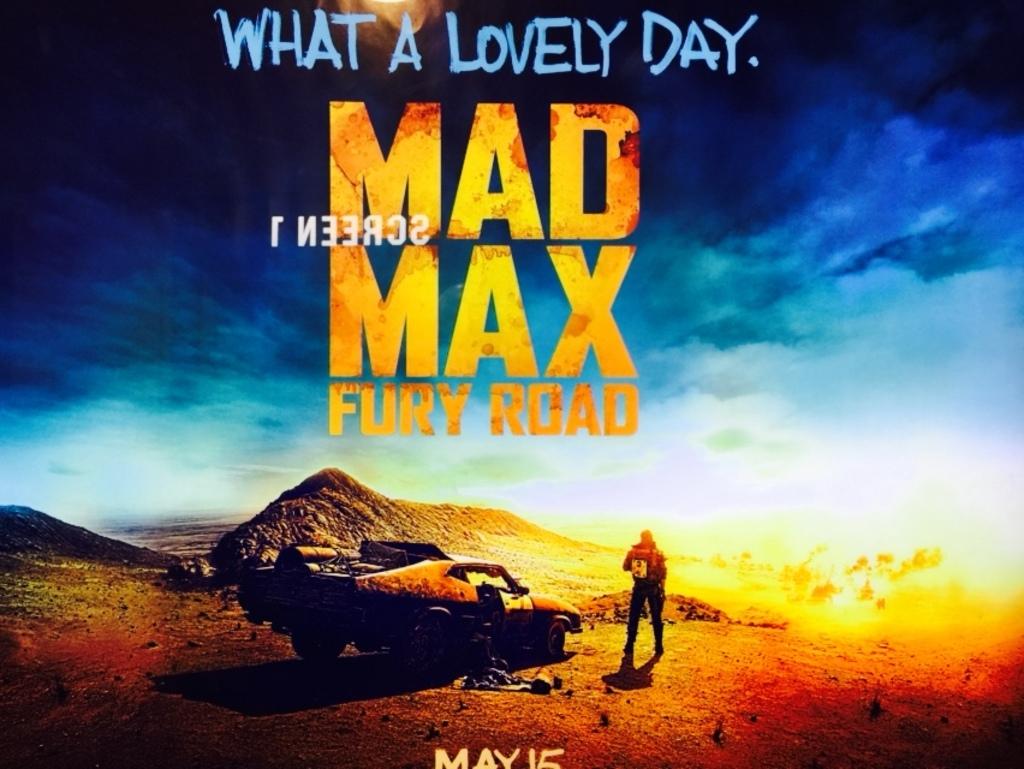What is the name of this movie?
Provide a succinct answer. Mad max fury road. Which mad max is this?
Keep it short and to the point. Fury road. 